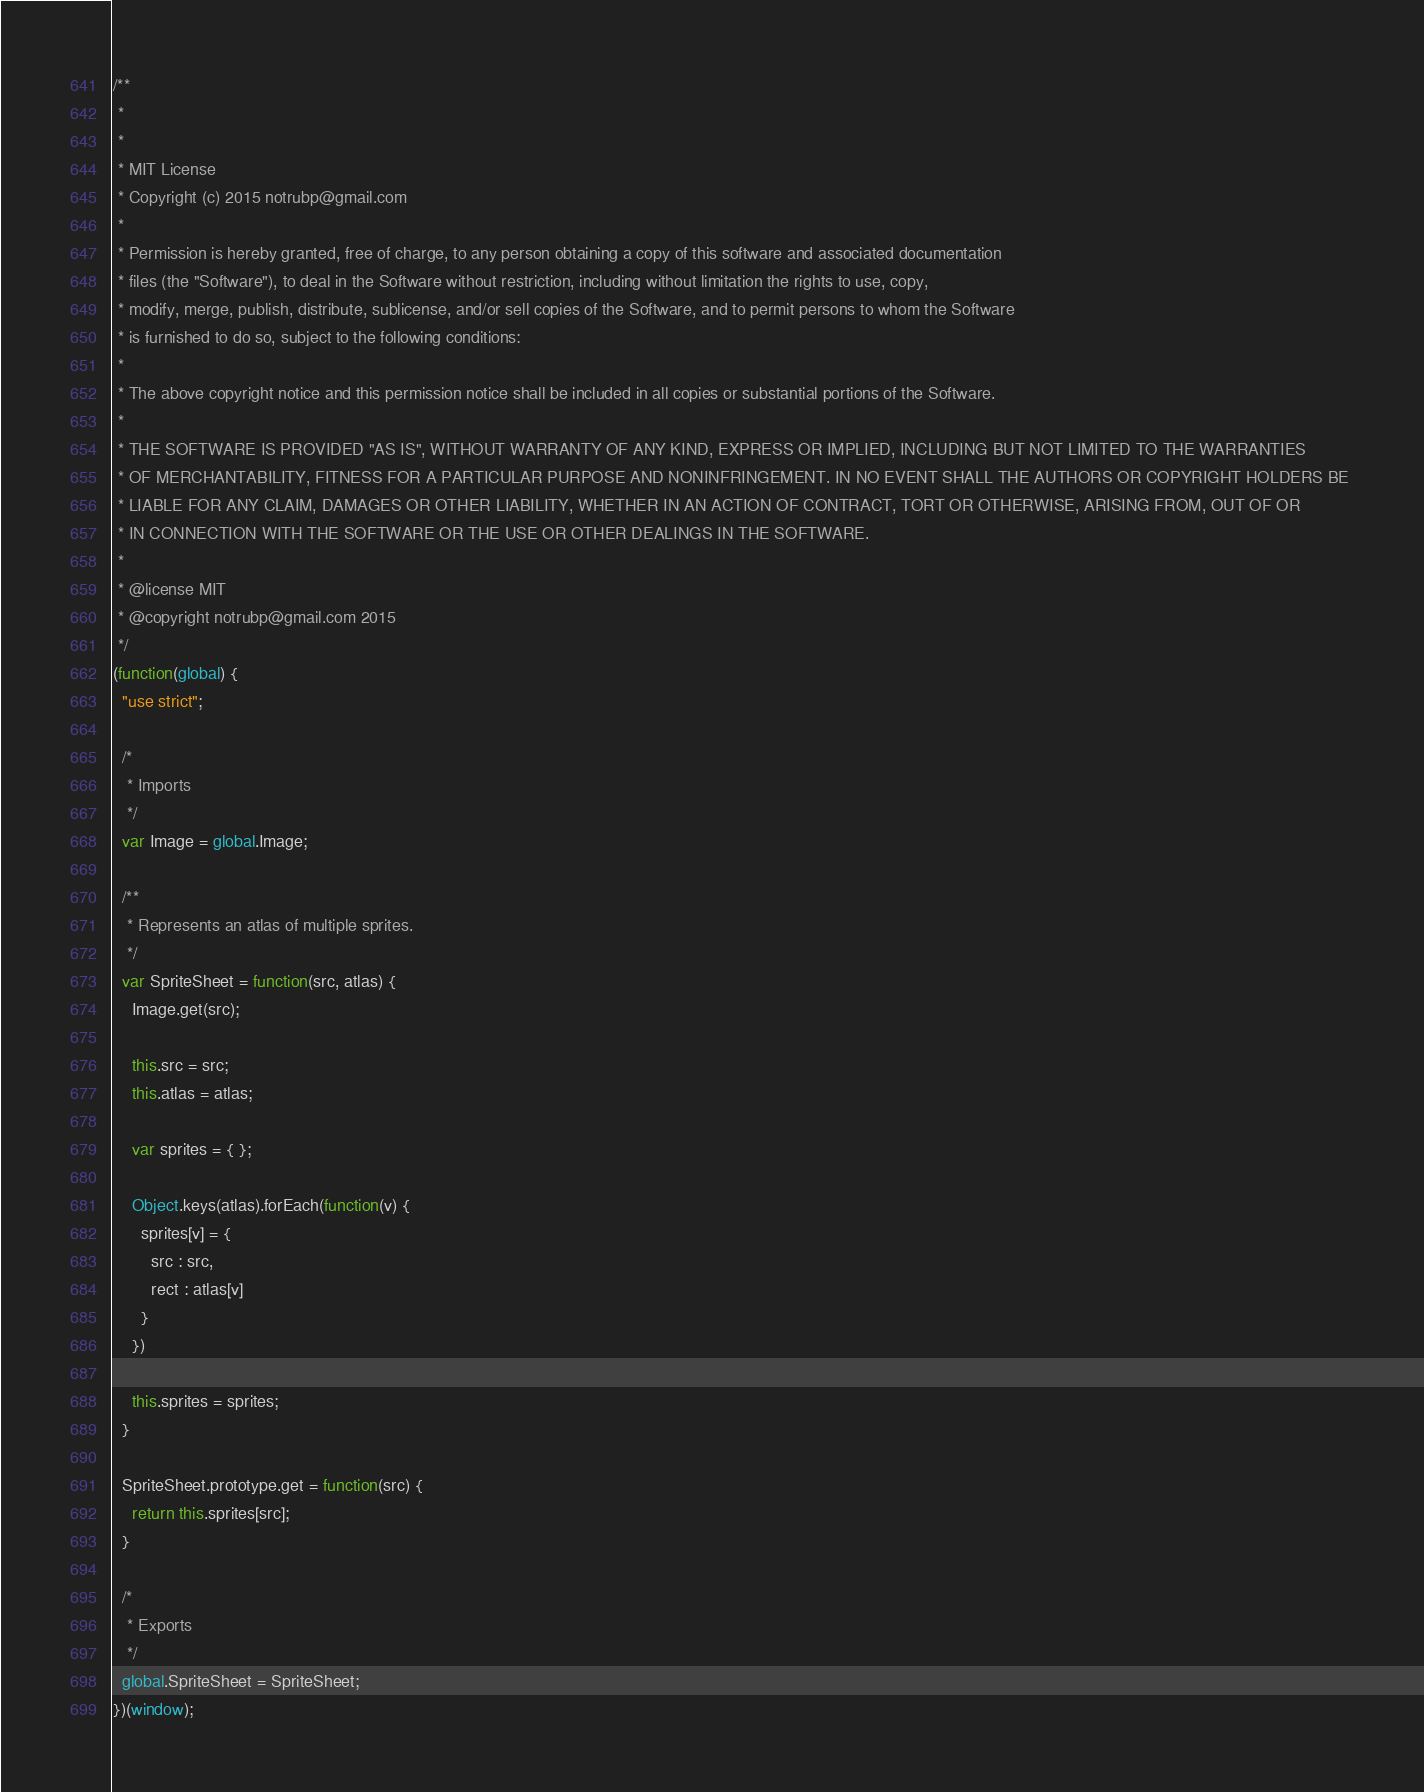Convert code to text. <code><loc_0><loc_0><loc_500><loc_500><_JavaScript_>/**
 * 
 *
 * MIT License
 * Copyright (c) 2015 notrubp@gmail.com
 *
 * Permission is hereby granted, free of charge, to any person obtaining a copy of this software and associated documentation 
 * files (the "Software"), to deal in the Software without restriction, including without limitation the rights to use, copy, 
 * modify, merge, publish, distribute, sublicense, and/or sell copies of the Software, and to permit persons to whom the Software 
 * is furnished to do so, subject to the following conditions:
 *
 * The above copyright notice and this permission notice shall be included in all copies or substantial portions of the Software.
 *
 * THE SOFTWARE IS PROVIDED "AS IS", WITHOUT WARRANTY OF ANY KIND, EXPRESS OR IMPLIED, INCLUDING BUT NOT LIMITED TO THE WARRANTIES 
 * OF MERCHANTABILITY, FITNESS FOR A PARTICULAR PURPOSE AND NONINFRINGEMENT. IN NO EVENT SHALL THE AUTHORS OR COPYRIGHT HOLDERS BE 
 * LIABLE FOR ANY CLAIM, DAMAGES OR OTHER LIABILITY, WHETHER IN AN ACTION OF CONTRACT, TORT OR OTHERWISE, ARISING FROM, OUT OF OR 
 * IN CONNECTION WITH THE SOFTWARE OR THE USE OR OTHER DEALINGS IN THE SOFTWARE.
 *
 * @license MIT
 * @copyright notrubp@gmail.com 2015
 */
(function(global) {
  "use strict";

  /*
   * Imports
   */
  var Image = global.Image;

  /**
   * Represents an atlas of multiple sprites.
   */
  var SpriteSheet = function(src, atlas) {
    Image.get(src);

    this.src = src;
    this.atlas = atlas;

    var sprites = { };

    Object.keys(atlas).forEach(function(v) {
      sprites[v] = {
        src : src,
        rect : atlas[v]
      }
    })

    this.sprites = sprites;
  }

  SpriteSheet.prototype.get = function(src) {
    return this.sprites[src];
  }

  /*
   * Exports
   */
  global.SpriteSheet = SpriteSheet;
})(window);


</code> 